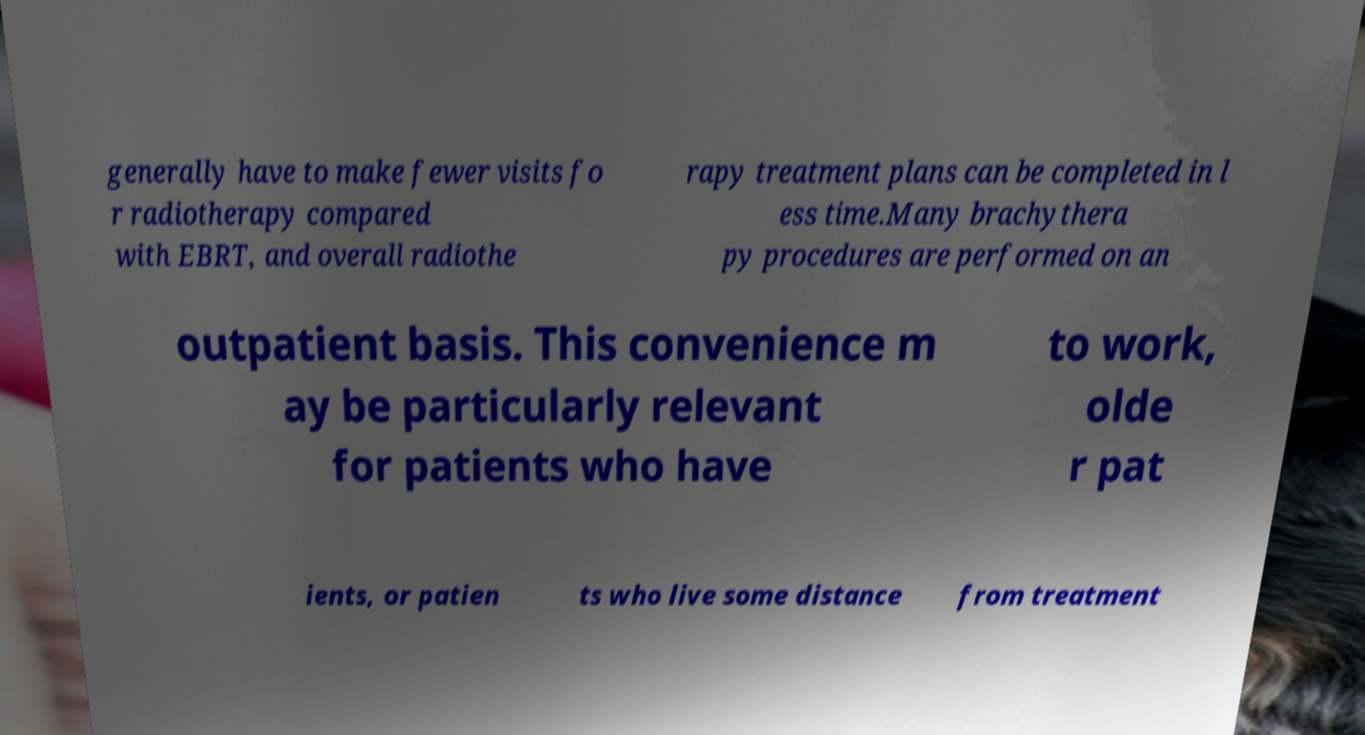There's text embedded in this image that I need extracted. Can you transcribe it verbatim? generally have to make fewer visits fo r radiotherapy compared with EBRT, and overall radiothe rapy treatment plans can be completed in l ess time.Many brachythera py procedures are performed on an outpatient basis. This convenience m ay be particularly relevant for patients who have to work, olde r pat ients, or patien ts who live some distance from treatment 